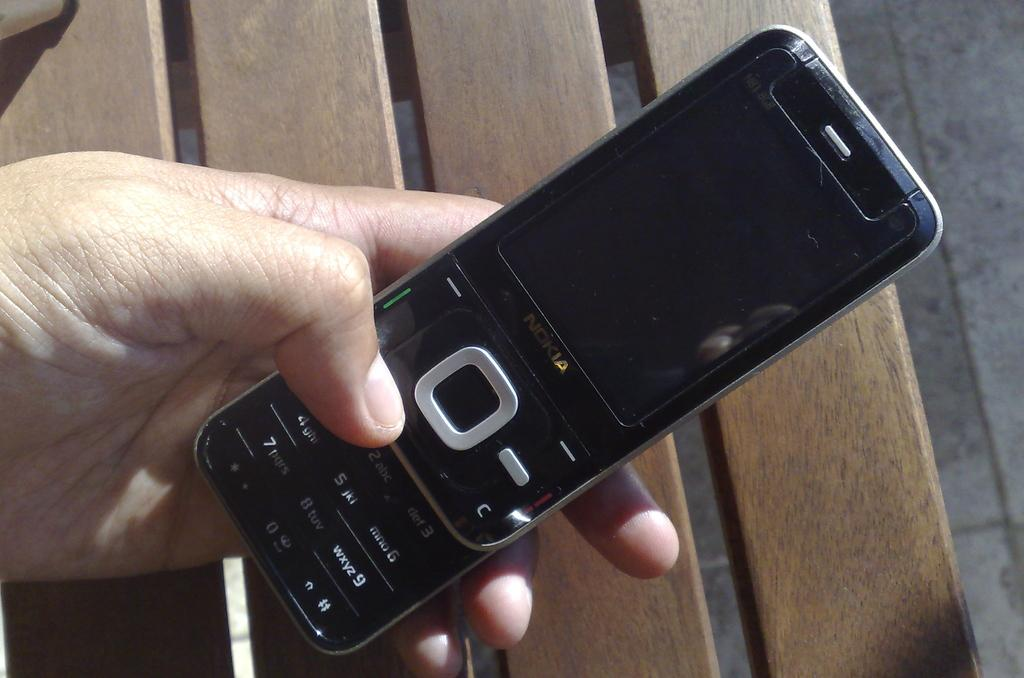<image>
Offer a succinct explanation of the picture presented. Someone holds a black Nokia sliding phone in their hand. 